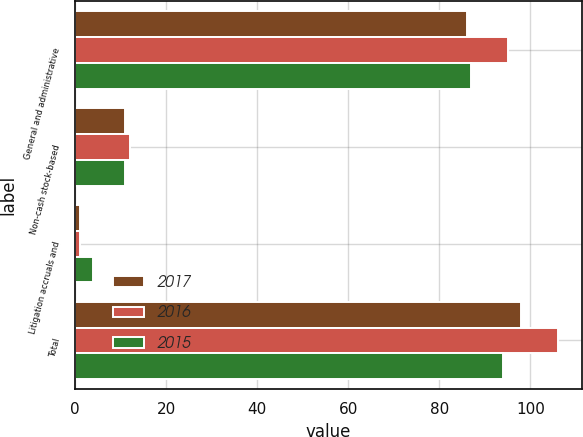Convert chart to OTSL. <chart><loc_0><loc_0><loc_500><loc_500><stacked_bar_chart><ecel><fcel>General and administrative<fcel>Non-cash stock-based<fcel>Litigation accruals and<fcel>Total<nl><fcel>2017<fcel>86<fcel>11<fcel>1<fcel>98<nl><fcel>2016<fcel>95<fcel>12<fcel>1<fcel>106<nl><fcel>2015<fcel>87<fcel>11<fcel>4<fcel>94<nl></chart> 